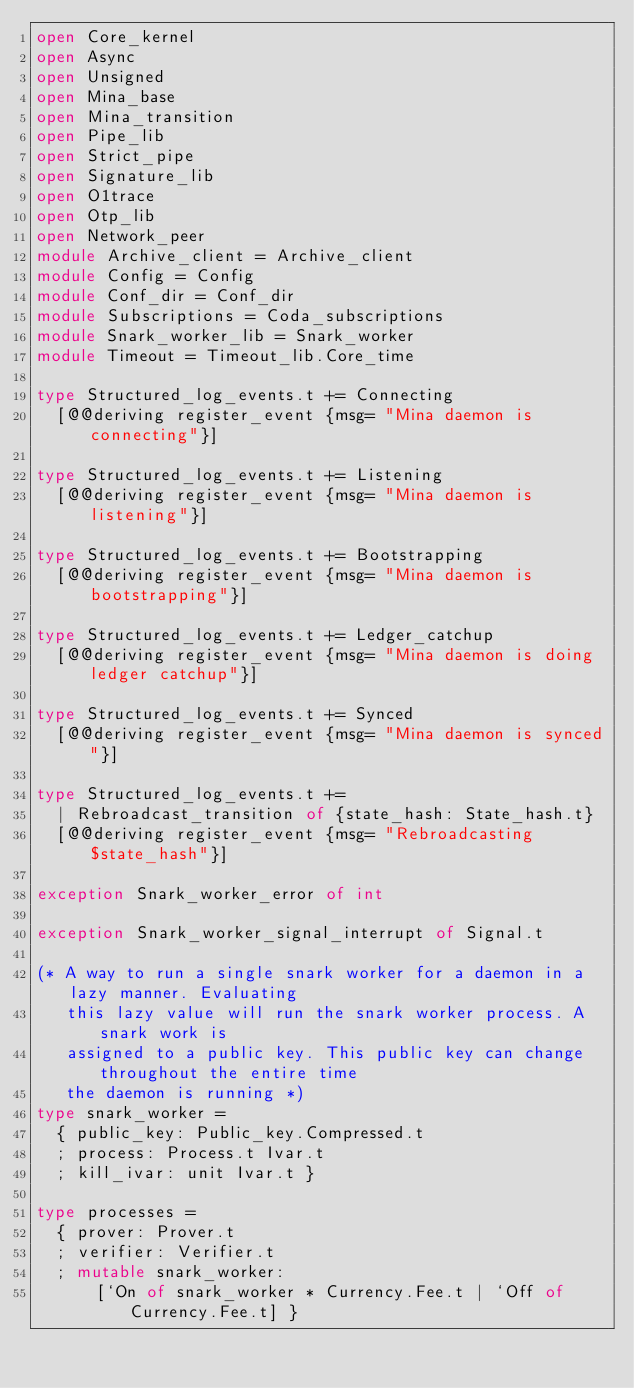<code> <loc_0><loc_0><loc_500><loc_500><_OCaml_>open Core_kernel
open Async
open Unsigned
open Mina_base
open Mina_transition
open Pipe_lib
open Strict_pipe
open Signature_lib
open O1trace
open Otp_lib
open Network_peer
module Archive_client = Archive_client
module Config = Config
module Conf_dir = Conf_dir
module Subscriptions = Coda_subscriptions
module Snark_worker_lib = Snark_worker
module Timeout = Timeout_lib.Core_time

type Structured_log_events.t += Connecting
  [@@deriving register_event {msg= "Mina daemon is connecting"}]

type Structured_log_events.t += Listening
  [@@deriving register_event {msg= "Mina daemon is listening"}]

type Structured_log_events.t += Bootstrapping
  [@@deriving register_event {msg= "Mina daemon is bootstrapping"}]

type Structured_log_events.t += Ledger_catchup
  [@@deriving register_event {msg= "Mina daemon is doing ledger catchup"}]

type Structured_log_events.t += Synced
  [@@deriving register_event {msg= "Mina daemon is synced"}]

type Structured_log_events.t +=
  | Rebroadcast_transition of {state_hash: State_hash.t}
  [@@deriving register_event {msg= "Rebroadcasting $state_hash"}]

exception Snark_worker_error of int

exception Snark_worker_signal_interrupt of Signal.t

(* A way to run a single snark worker for a daemon in a lazy manner. Evaluating
   this lazy value will run the snark worker process. A snark work is
   assigned to a public key. This public key can change throughout the entire time
   the daemon is running *)
type snark_worker =
  { public_key: Public_key.Compressed.t
  ; process: Process.t Ivar.t
  ; kill_ivar: unit Ivar.t }

type processes =
  { prover: Prover.t
  ; verifier: Verifier.t
  ; mutable snark_worker:
      [`On of snark_worker * Currency.Fee.t | `Off of Currency.Fee.t] }
</code> 